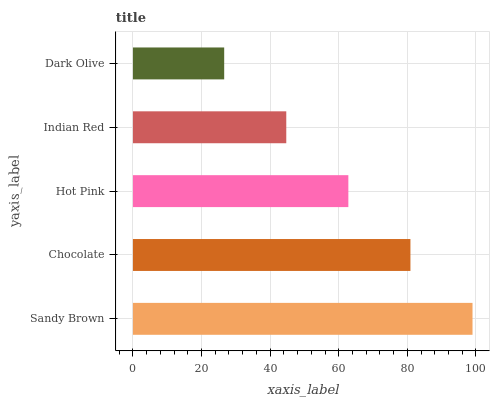Is Dark Olive the minimum?
Answer yes or no. Yes. Is Sandy Brown the maximum?
Answer yes or no. Yes. Is Chocolate the minimum?
Answer yes or no. No. Is Chocolate the maximum?
Answer yes or no. No. Is Sandy Brown greater than Chocolate?
Answer yes or no. Yes. Is Chocolate less than Sandy Brown?
Answer yes or no. Yes. Is Chocolate greater than Sandy Brown?
Answer yes or no. No. Is Sandy Brown less than Chocolate?
Answer yes or no. No. Is Hot Pink the high median?
Answer yes or no. Yes. Is Hot Pink the low median?
Answer yes or no. Yes. Is Chocolate the high median?
Answer yes or no. No. Is Indian Red the low median?
Answer yes or no. No. 